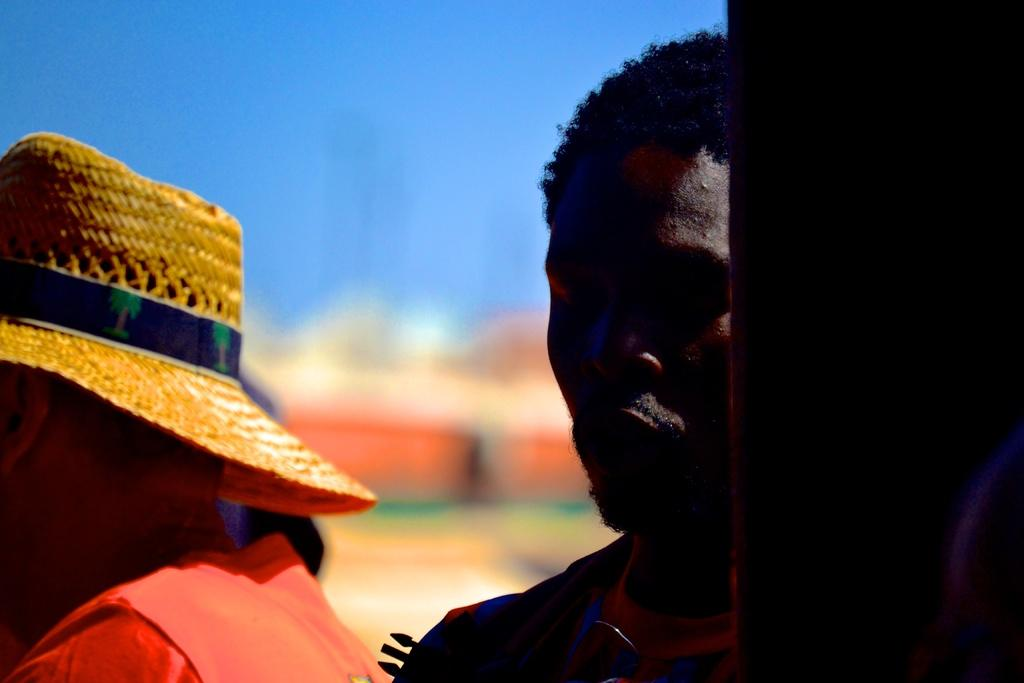How many people are present in the image? There are two people in the image. Can you describe the clothing of one of the people? One of the people is wearing a hat. What can be observed about the background of the image? The background of the image is blurred. What does the dad say when the balloon bursts in the image? There is no dad or balloon present in the image, so it is not possible to answer that question. 